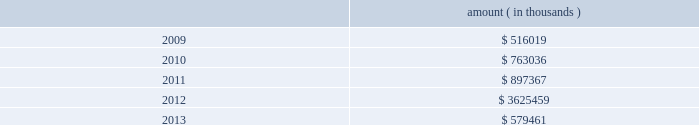Entergy corporation and subsidiaries notes to financial statements ( a ) consists of pollution control revenue bonds and environmental revenue bonds .
( b ) the bonds are secured by a series of collateral first mortgage bonds .
( c ) in december 2005 , entergy corporation sold 10 million equity units with a stated amount of $ 50 each .
An equity unit consisted of ( 1 ) a note , initially due february 2011 and initially bearing interest at an annual rate of 5.75% ( 5.75 % ) , and ( 2 ) a purchase contract that obligated the holder of the equity unit to purchase for $ 50 between 0.5705 and 0.7074 shares of entergy corporation common stock on or before february 17 , 2009 .
Entergy paid the holders quarterly contract adjustment payments of 1.875% ( 1.875 % ) per year on the stated amount of $ 50 per equity unit .
Under the terms of the purchase contracts , entergy attempted to remarket the notes in february 2009 but was unsuccessful , the note holders put the notes to entergy , entergy retired the notes , and entergy issued 6598000 shares of common stock in the settlement of the purchase contracts .
( d ) pursuant to the nuclear waste policy act of 1982 , entergy's nuclear owner/licensee subsidiaries have contracts with the doe for spent nuclear fuel disposal service .
The contracts include a one-time fee for generation prior to april 7 , 1983 .
Entergy arkansas is the only entergy company that generated electric power with nuclear fuel prior to that date and includes the one-time fee , plus accrued interest , in long-term ( e ) the fair value excludes lease obligations , long-term doe obligations , and the note payable to nypa , and includes debt due within one year .
It is determined using bid prices reported by dealer markets and by nationally recognized investment banking firms .
( f ) entergy gulf states louisiana remains primarily liable for all of the long-term debt issued by entergy gulf states , inc .
That was outstanding on december 31 , 2008 and 2007 .
Under a debt assumption agreement with entergy gulf states louisiana , entergy texas assumed approximately 46% ( 46 % ) of this long-term debt .
The annual long-term debt maturities ( excluding lease obligations ) for debt outstanding as of december 31 , 2008 , for the next five years are as follows : amount ( in thousands ) .
In november 2000 , entergy's non-utility nuclear business purchased the fitzpatrick and indian point 3 power plants in a seller-financed transaction .
Entergy issued notes to nypa with seven annual installments of approximately $ 108 million commencing one year from the date of the closing , and eight annual installments of $ 20 million commencing eight years from the date of the closing .
These notes do not have a stated interest rate , but have an implicit interest rate of 4.8% ( 4.8 % ) .
In accordance with the purchase agreement with nypa , the purchase of indian point 2 in 2001 resulted in entergy's non-utility nuclear business becoming liable to nypa for an additional $ 10 million per year for 10 years , beginning in september 2003 .
This liability was recorded upon the purchase of indian point 2 in september 2001 , and is included in the note payable to nypa balance above .
In july 2003 , a payment of $ 102 million was made prior to maturity on the note payable to nypa .
Under a provision in a letter of credit supporting these notes , if certain of the utility operating companies or system energy were to default on other indebtedness , entergy could be required to post collateral to support the letter of credit .
Covenants in the entergy corporation notes require it to maintain a consolidated debt ratio of 65% ( 65 % ) or less of its total capitalization .
If entergy's debt ratio exceeds this limit , or if entergy or certain of the utility operating companies default on other indebtedness or are in bankruptcy or insolvency proceedings , an acceleration of the notes' maturity dates may occur .
Entergy gulf states louisiana , entergy louisiana , entergy mississippi , entergy texas , and system energy have received ferc long-term financing orders authorizing long-term securities issuances .
Entergy arkansas has .
As of december 2008 what was the sum of the annual long-term debt maturities due in five years? 
Computations: (579461 + (3625459 + ((516019 + 763036) + 897367)))
Answer: 6381342.0. Entergy corporation and subsidiaries notes to financial statements ( a ) consists of pollution control revenue bonds and environmental revenue bonds .
( b ) the bonds are secured by a series of collateral first mortgage bonds .
( c ) in december 2005 , entergy corporation sold 10 million equity units with a stated amount of $ 50 each .
An equity unit consisted of ( 1 ) a note , initially due february 2011 and initially bearing interest at an annual rate of 5.75% ( 5.75 % ) , and ( 2 ) a purchase contract that obligated the holder of the equity unit to purchase for $ 50 between 0.5705 and 0.7074 shares of entergy corporation common stock on or before february 17 , 2009 .
Entergy paid the holders quarterly contract adjustment payments of 1.875% ( 1.875 % ) per year on the stated amount of $ 50 per equity unit .
Under the terms of the purchase contracts , entergy attempted to remarket the notes in february 2009 but was unsuccessful , the note holders put the notes to entergy , entergy retired the notes , and entergy issued 6598000 shares of common stock in the settlement of the purchase contracts .
( d ) pursuant to the nuclear waste policy act of 1982 , entergy's nuclear owner/licensee subsidiaries have contracts with the doe for spent nuclear fuel disposal service .
The contracts include a one-time fee for generation prior to april 7 , 1983 .
Entergy arkansas is the only entergy company that generated electric power with nuclear fuel prior to that date and includes the one-time fee , plus accrued interest , in long-term ( e ) the fair value excludes lease obligations , long-term doe obligations , and the note payable to nypa , and includes debt due within one year .
It is determined using bid prices reported by dealer markets and by nationally recognized investment banking firms .
( f ) entergy gulf states louisiana remains primarily liable for all of the long-term debt issued by entergy gulf states , inc .
That was outstanding on december 31 , 2008 and 2007 .
Under a debt assumption agreement with entergy gulf states louisiana , entergy texas assumed approximately 46% ( 46 % ) of this long-term debt .
The annual long-term debt maturities ( excluding lease obligations ) for debt outstanding as of december 31 , 2008 , for the next five years are as follows : amount ( in thousands ) .
In november 2000 , entergy's non-utility nuclear business purchased the fitzpatrick and indian point 3 power plants in a seller-financed transaction .
Entergy issued notes to nypa with seven annual installments of approximately $ 108 million commencing one year from the date of the closing , and eight annual installments of $ 20 million commencing eight years from the date of the closing .
These notes do not have a stated interest rate , but have an implicit interest rate of 4.8% ( 4.8 % ) .
In accordance with the purchase agreement with nypa , the purchase of indian point 2 in 2001 resulted in entergy's non-utility nuclear business becoming liable to nypa for an additional $ 10 million per year for 10 years , beginning in september 2003 .
This liability was recorded upon the purchase of indian point 2 in september 2001 , and is included in the note payable to nypa balance above .
In july 2003 , a payment of $ 102 million was made prior to maturity on the note payable to nypa .
Under a provision in a letter of credit supporting these notes , if certain of the utility operating companies or system energy were to default on other indebtedness , entergy could be required to post collateral to support the letter of credit .
Covenants in the entergy corporation notes require it to maintain a consolidated debt ratio of 65% ( 65 % ) or less of its total capitalization .
If entergy's debt ratio exceeds this limit , or if entergy or certain of the utility operating companies default on other indebtedness or are in bankruptcy or insolvency proceedings , an acceleration of the notes' maturity dates may occur .
Entergy gulf states louisiana , entergy louisiana , entergy mississippi , entergy texas , and system energy have received ferc long-term financing orders authorizing long-term securities issuances .
Entergy arkansas has .
What was the sum of the notes entergy issued to nypa with eight and seven annual installment payments? 
Computations: ((8 * 20) + (108 * 7))
Answer: 916.0. 